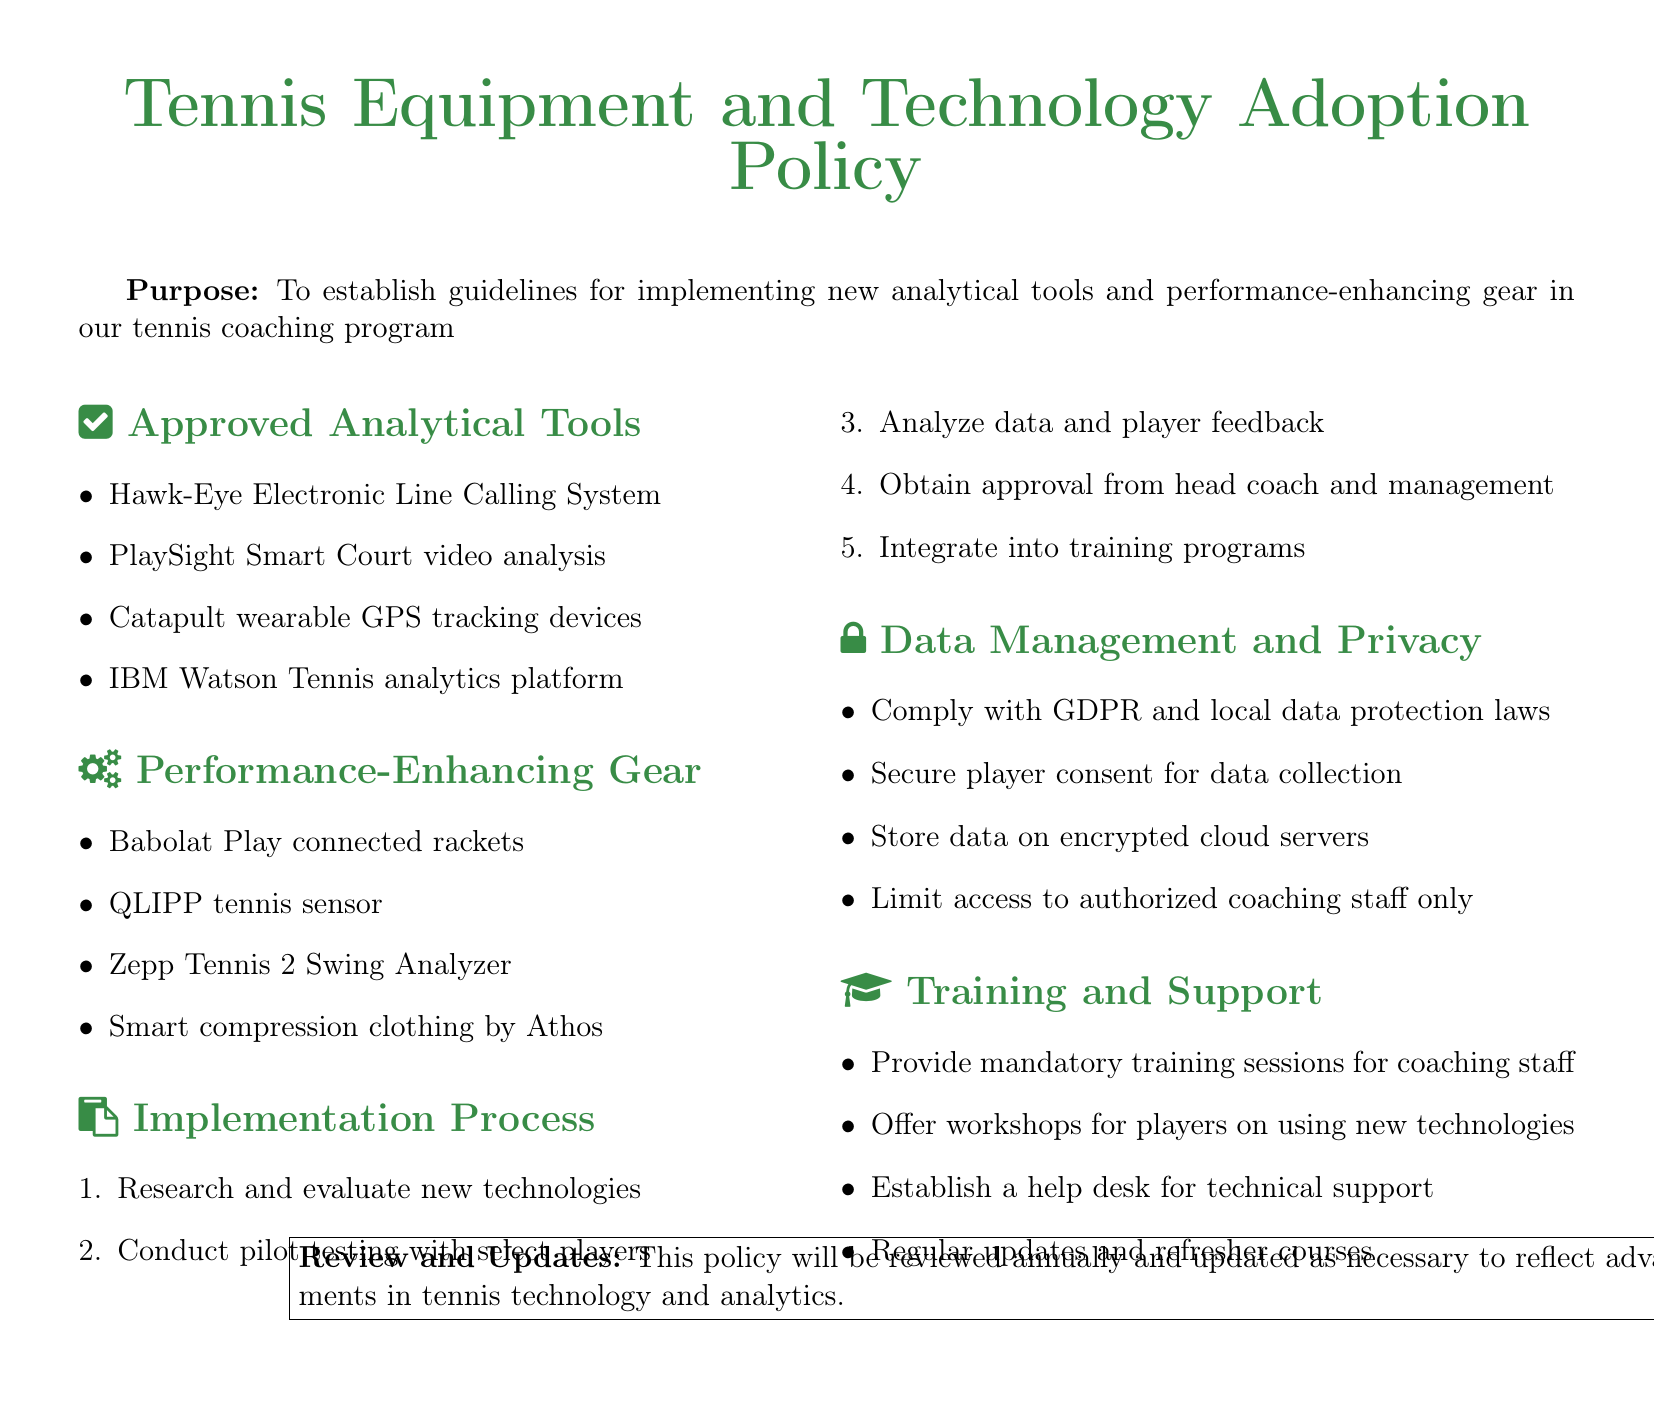What is the purpose of the policy? The purpose is stated in the document to establish guidelines for implementing new analytical tools and performance-enhancing gear in the tennis coaching program.
Answer: To establish guidelines for implementing new analytical tools and performance-enhancing gear in our tennis coaching program What is one of the approved analytical tools? The document lists approved analytical tools under a specific section, and one example is the Hawk-Eye system.
Answer: Hawk-Eye Electronic Line Calling System How many steps are in the implementation process? The implementation process is outlined in an enumerated list, which contains five distinct steps.
Answer: 5 Which company produces the connected rackets mentioned? The performance-enhancing gear section specifies that Babolat manufactures the connected rackets.
Answer: Babolat What is required to comply with data management? The document emphasizes several mandates under data management, one of which is compliance with GDPR.
Answer: GDPR What type of training is provided for staff? The policy specifies that mandatory training sessions are provided for coaching staff.
Answer: Mandatory training sessions How often will the policy be reviewed? The document states that the policy will be reviewed on an annual basis.
Answer: Annually Who must provide consent for data collection? The document dictates that player consent is required for data collection.
Answer: Players 